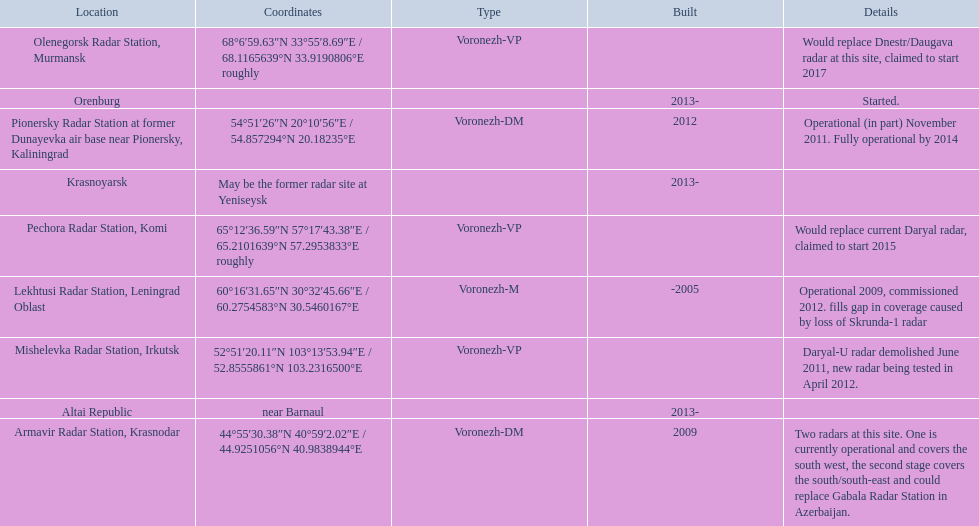What is the total number of locations? 9. 